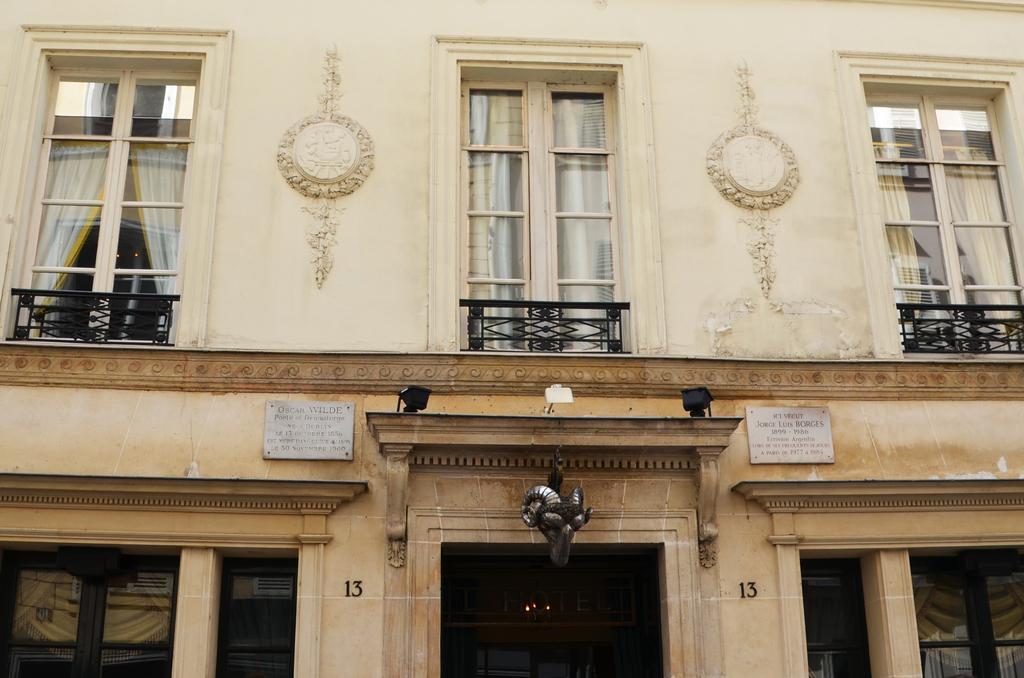How would you summarize this image in a sentence or two? In this image there is a building. There are glass windows and railing to the walls of the building. There are sculptures on the wall. There are lights on the walls. Beside the lights there are boards with text on the walls. 